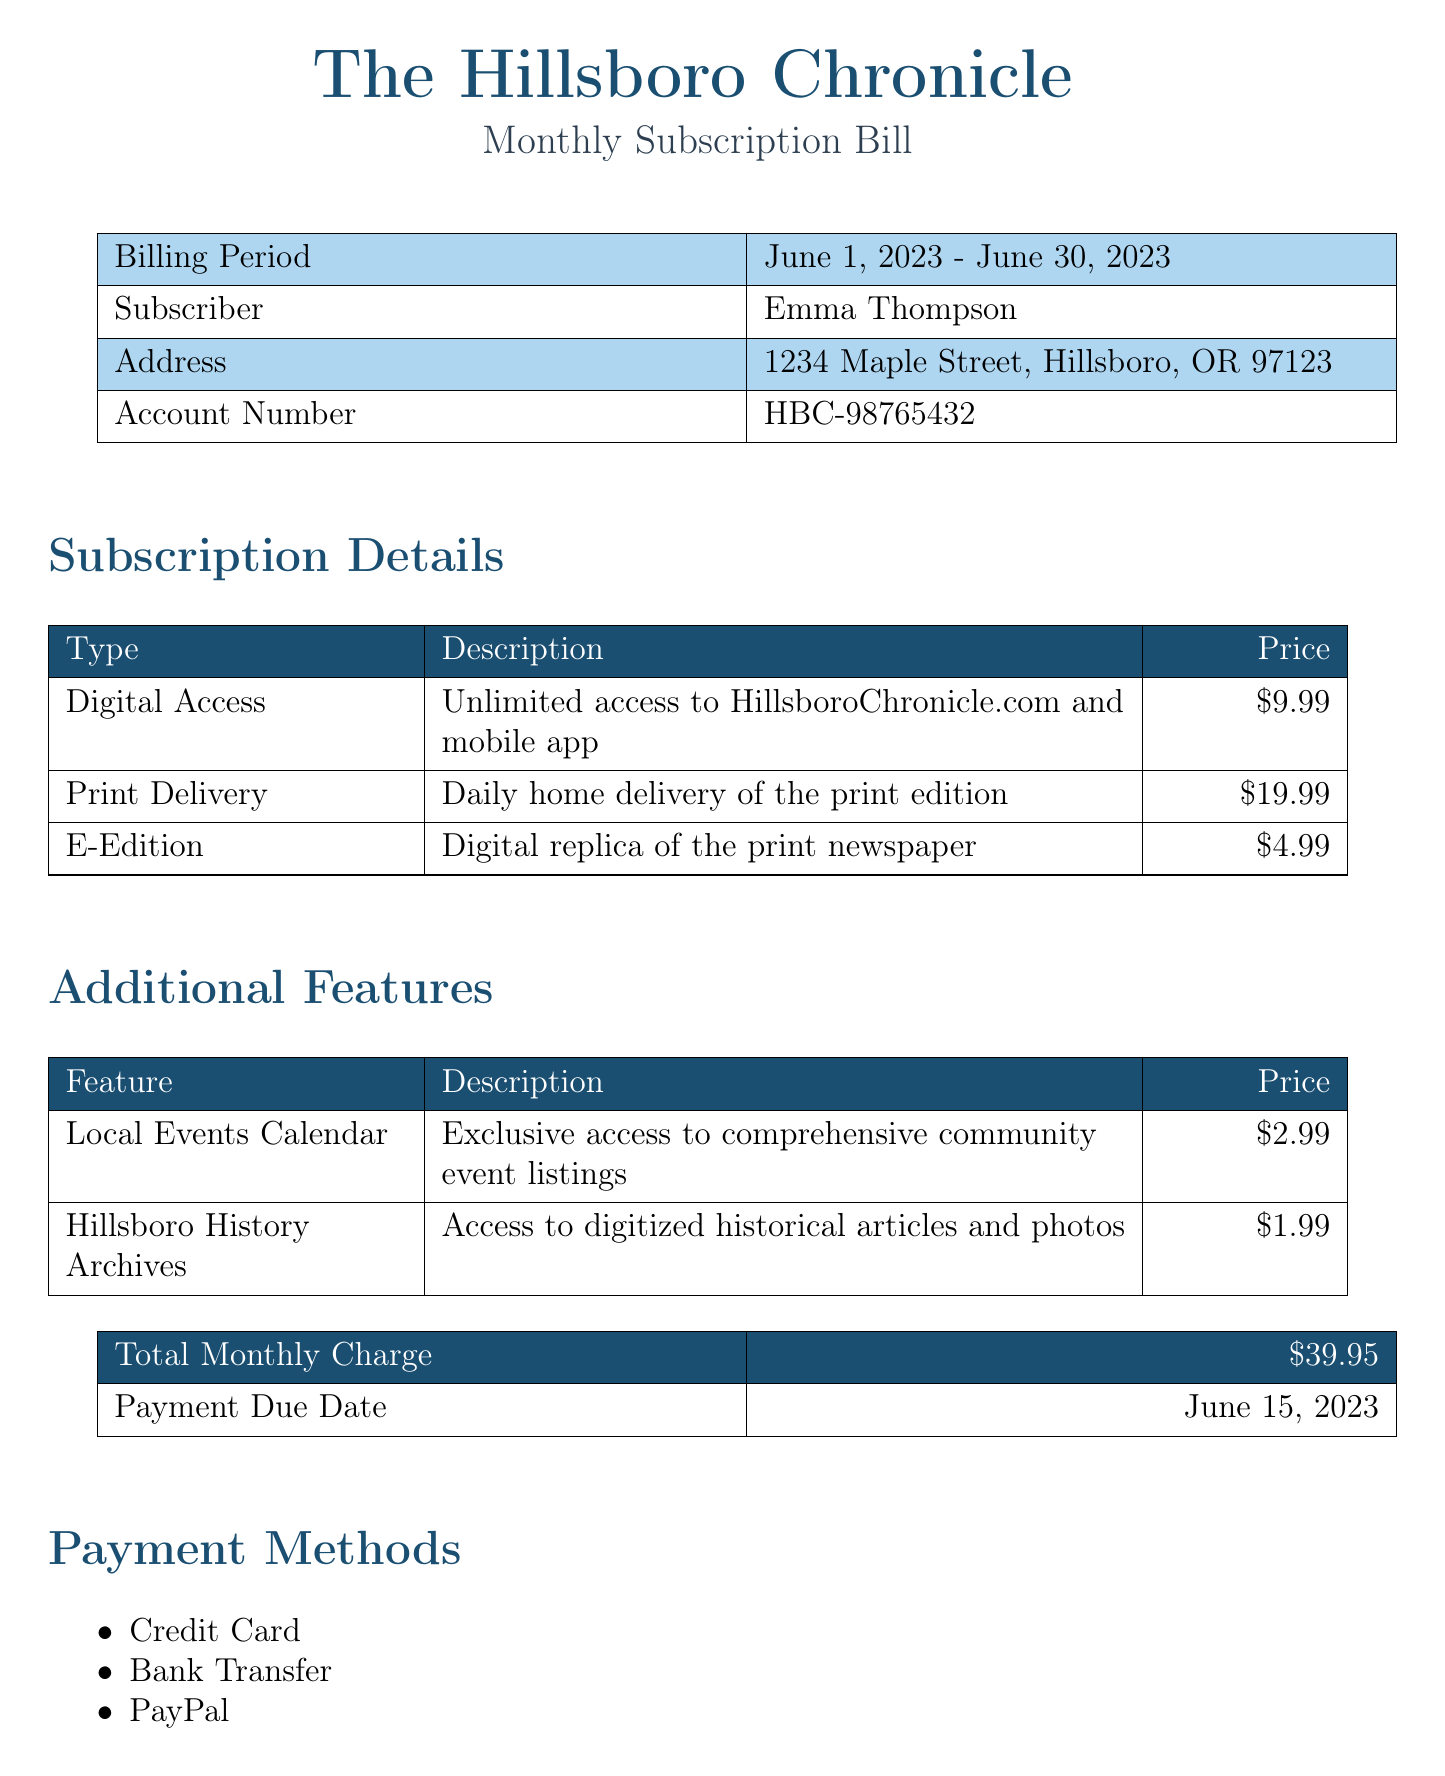What is the billing period? The billing period is stated in the document, which specifies the dates covered by this bill.
Answer: June 1, 2023 - June 30, 2023 Who is the subscriber? The subscriber's name is provided at the top of the bill, indicating who the subscription is for.
Answer: Emma Thompson What is the price for digital access? The document lists prices for different subscription types, including digital access.
Answer: $9.99 What additional feature costs $1.99? The document lists additional features along with their respective prices, including this specific feature.
Answer: Hillsboro History Archives When is the payment due date? The due date for the payment is clearly mentioned in the billing details section of the document.
Answer: June 15, 2023 What is the total monthly charge? The total monthly charge is provided at the end of the billing details and sums up all the subscription components.
Answer: $39.95 Which payment method is NOT listed? The document includes a list of payment methods, and identifying the missing one requires comparing known methods.
Answer: None What is the special offer mentioned? The document contains a special offer that encourages subscribers to refer friends, which is detailed in the special offer section.
Answer: Refer a friend and get 10% off your next month's subscription! 